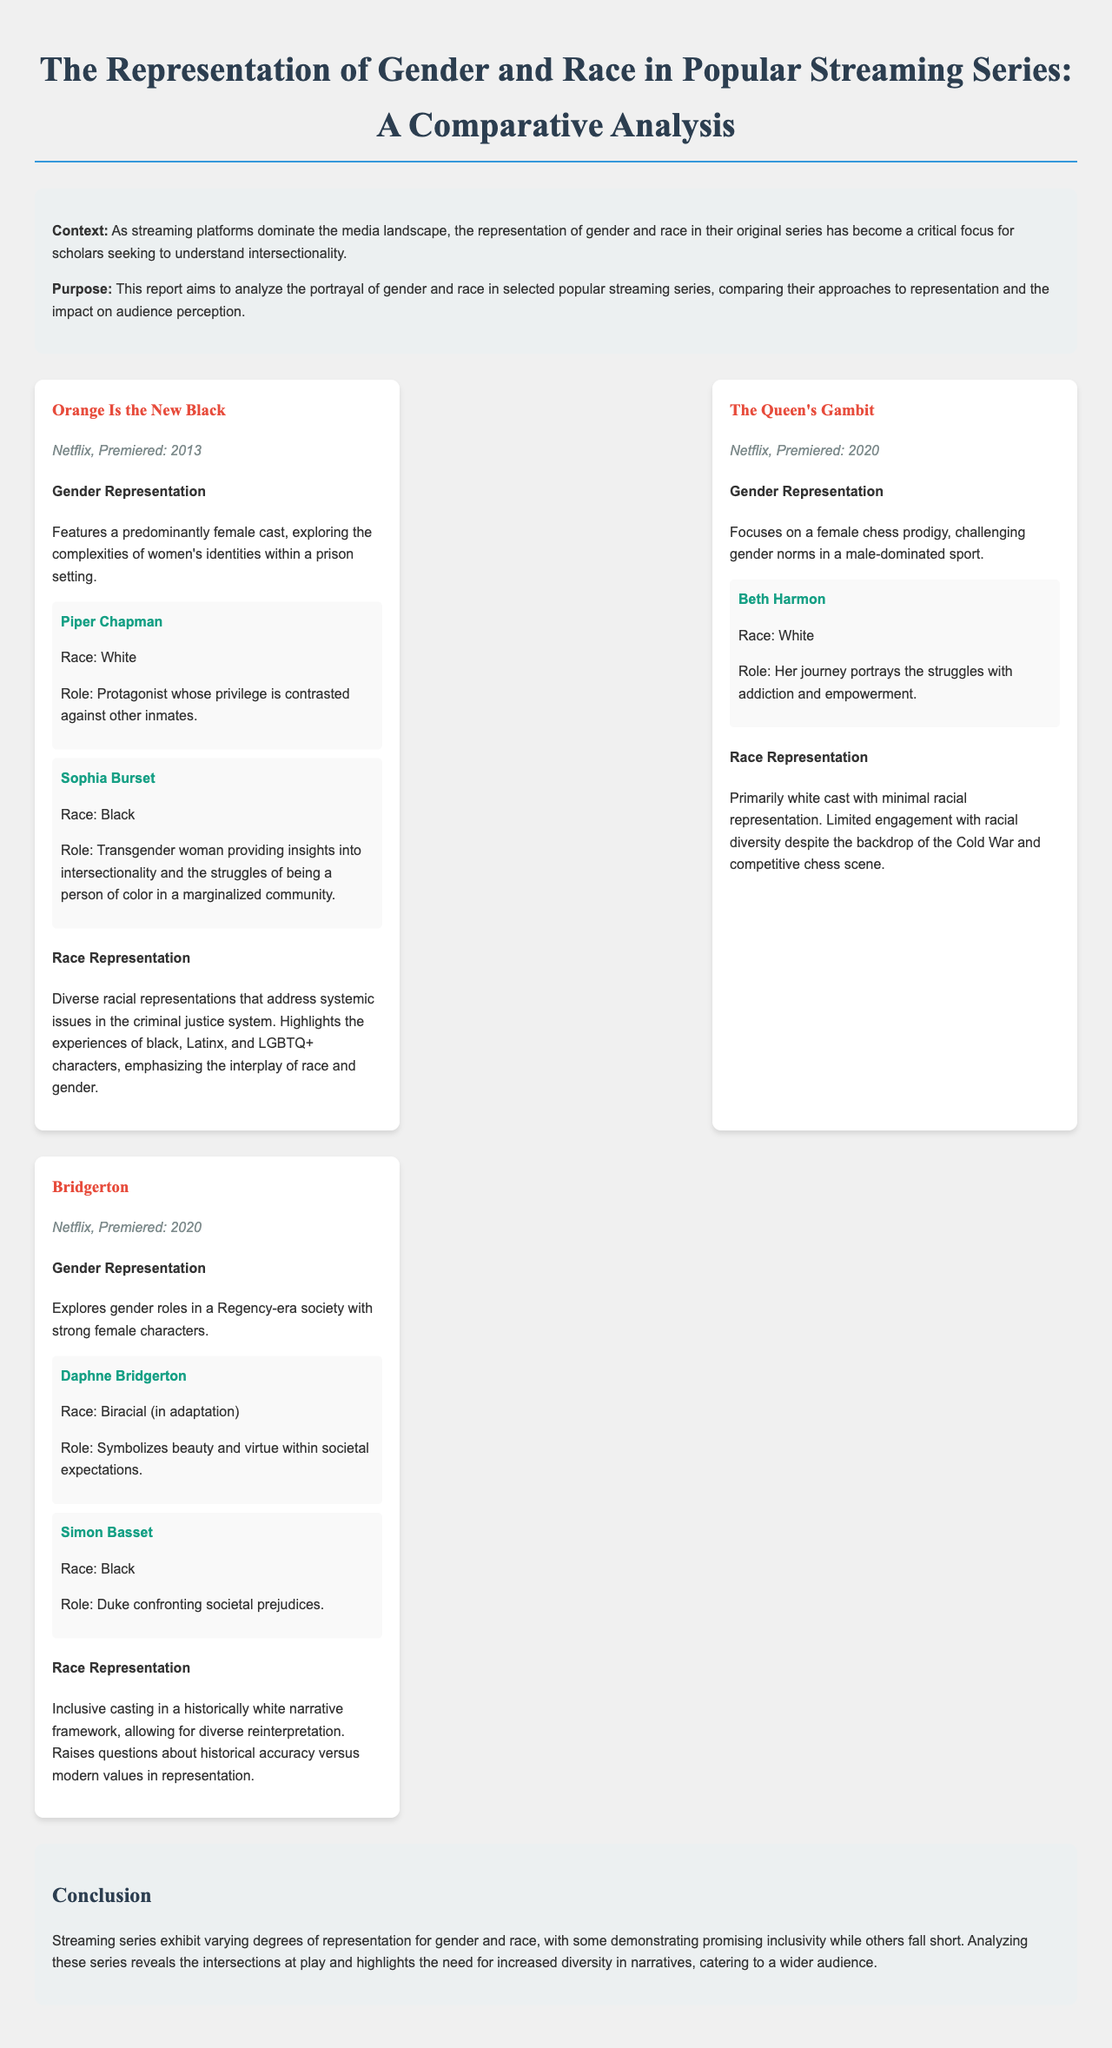What series premiered in 2013? The document states that "Orange Is the New Black" is the series that premiered in 2013.
Answer: Orange Is the New Black Who is the protagonist in "Orange Is the New Black"? According to the document, the protagonist of "Orange Is the New Black" is Piper Chapman.
Answer: Piper Chapman How many series are analyzed in the report? The report discusses three series: "Orange Is the New Black," "The Queen's Gambit," and "Bridgerton."
Answer: Three What does the character Sophia Burset represent? The document highlights that Sophia Burset provides insights into intersectionality and the struggles of being a person of color in a marginalized community.
Answer: Intersectionality Which series focuses on a female chess prodigy? The report specifies that "The Queen's Gambit" focuses on a female chess prodigy.
Answer: The Queen's Gambit What is the racial representation in "Bridgerton"? The document emphasizes that "Bridgerton" features inclusive casting in a historically white narrative framework.
Answer: Inclusive casting What year did "The Queen's Gambit" premiere? The document states that "The Queen's Gambit" premiered in 2020.
Answer: 2020 How does "Bridgerton" challenge societal expectations? The report mentions that "Bridgerton" explores gender roles in a Regency-era society with strong female characters.
Answer: Strong female characters 